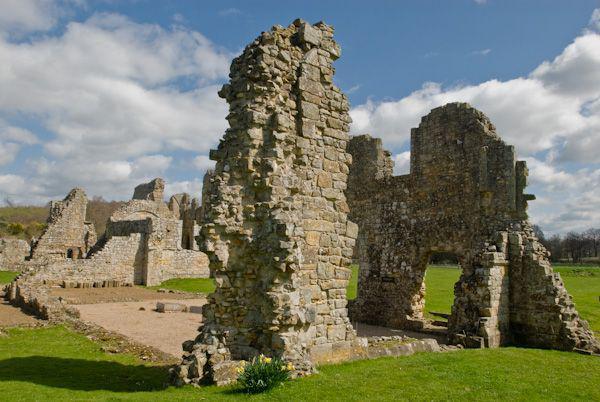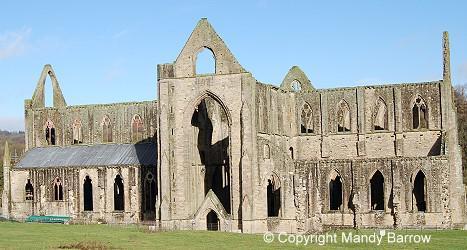The first image is the image on the left, the second image is the image on the right. Considering the images on both sides, is "In one image, a large arched opening reaches several stories, almost to the roof line, and is topped with a pointed stone which has a window opening." valid? Answer yes or no. Yes. The first image is the image on the left, the second image is the image on the right. For the images shown, is this caption "There are no trees near any of the buidlings pictured." true? Answer yes or no. Yes. 